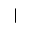Convert formula to latex. <formula><loc_0><loc_0><loc_500><loc_500>|</formula> 